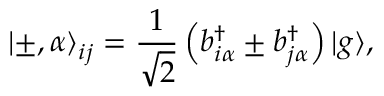Convert formula to latex. <formula><loc_0><loc_0><loc_500><loc_500>{ | \pm , \alpha \rangle } _ { i j } = \frac { 1 } { \sqrt { 2 } } \left ( b _ { i \alpha } ^ { \dagger } \pm b _ { j \alpha } ^ { \dagger } \right ) { | g \rangle } ,</formula> 